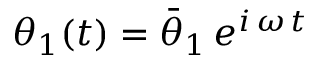<formula> <loc_0><loc_0><loc_500><loc_500>\theta _ { 1 } ( t ) = \bar { \theta } _ { 1 } \, e ^ { i \, \omega \, t }</formula> 